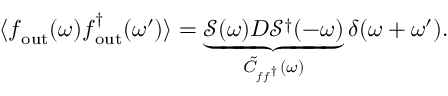Convert formula to latex. <formula><loc_0><loc_0><loc_500><loc_500>\langle f _ { o u t } ( \omega ) f _ { o u t } ^ { \dagger } ( \omega ^ { \prime } ) \rangle = \underbrace { \mathcal { S } ( \omega ) D \mathcal { S } ^ { \dagger } ( - \omega ) } _ { \tilde { C } _ { f f ^ { \dagger } } ( \omega ) } \delta ( \omega + \omega ^ { \prime } ) .</formula> 